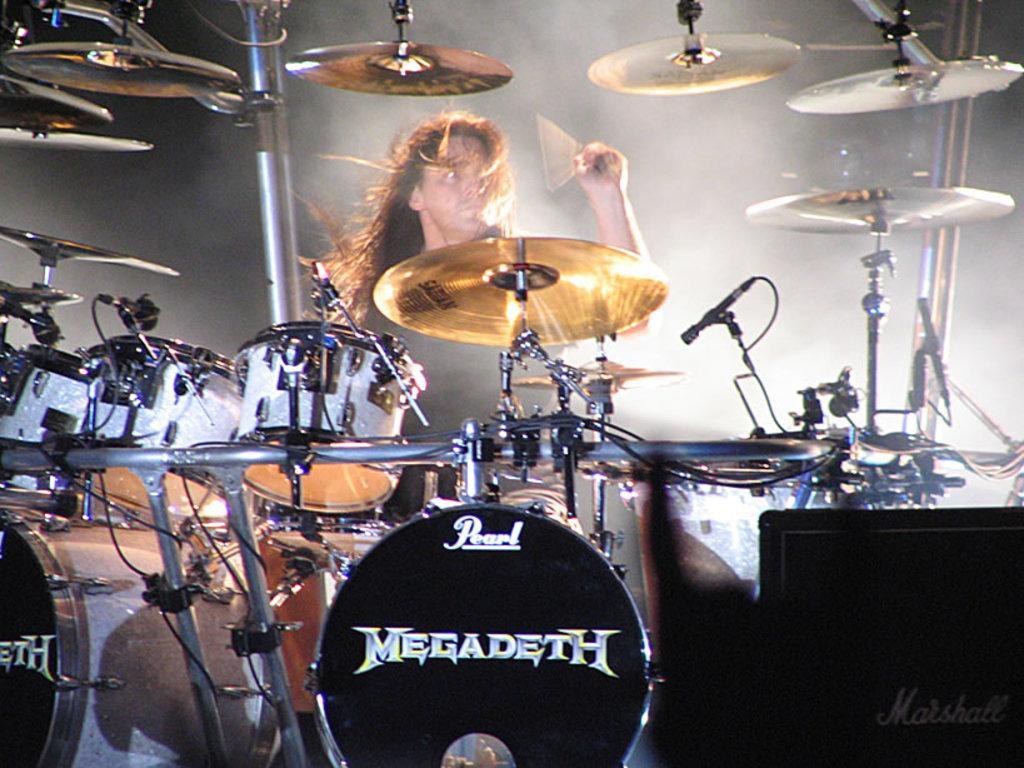In one or two sentences, can you explain what this image depicts? In this picture I can see a human playing drums with the help of sticks and I can see smoke in the back and I can see text on the drums. 